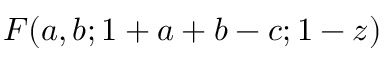<formula> <loc_0><loc_0><loc_500><loc_500>F ( a , b ; 1 + a + b - c ; 1 - z )</formula> 